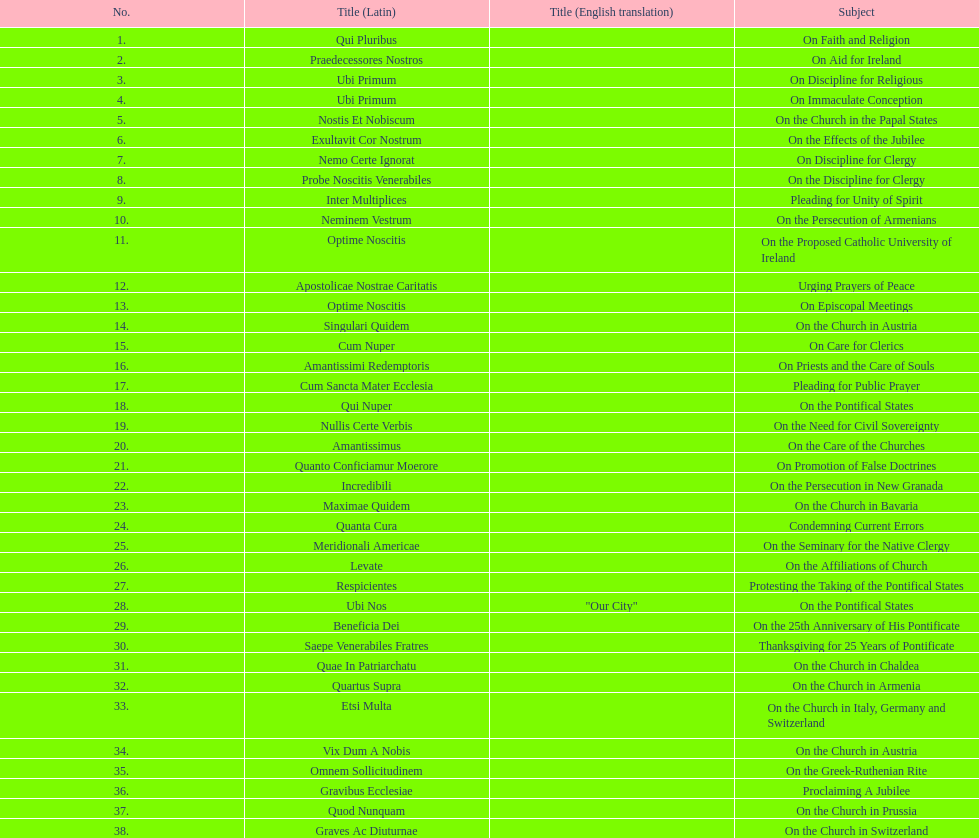What is the last title? Graves Ac Diuturnae. 